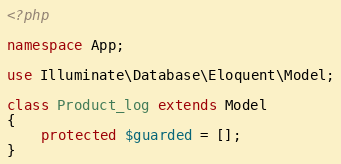Convert code to text. <code><loc_0><loc_0><loc_500><loc_500><_PHP_><?php

namespace App;

use Illuminate\Database\Eloquent\Model;

class Product_log extends Model
{
    protected $guarded = [];
}
</code> 